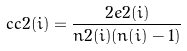<formula> <loc_0><loc_0><loc_500><loc_500>c c 2 ( i ) = \frac { 2 e 2 ( i ) } { n 2 ( i ) ( n ( i ) - 1 ) }</formula> 